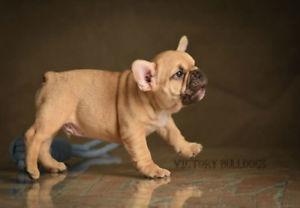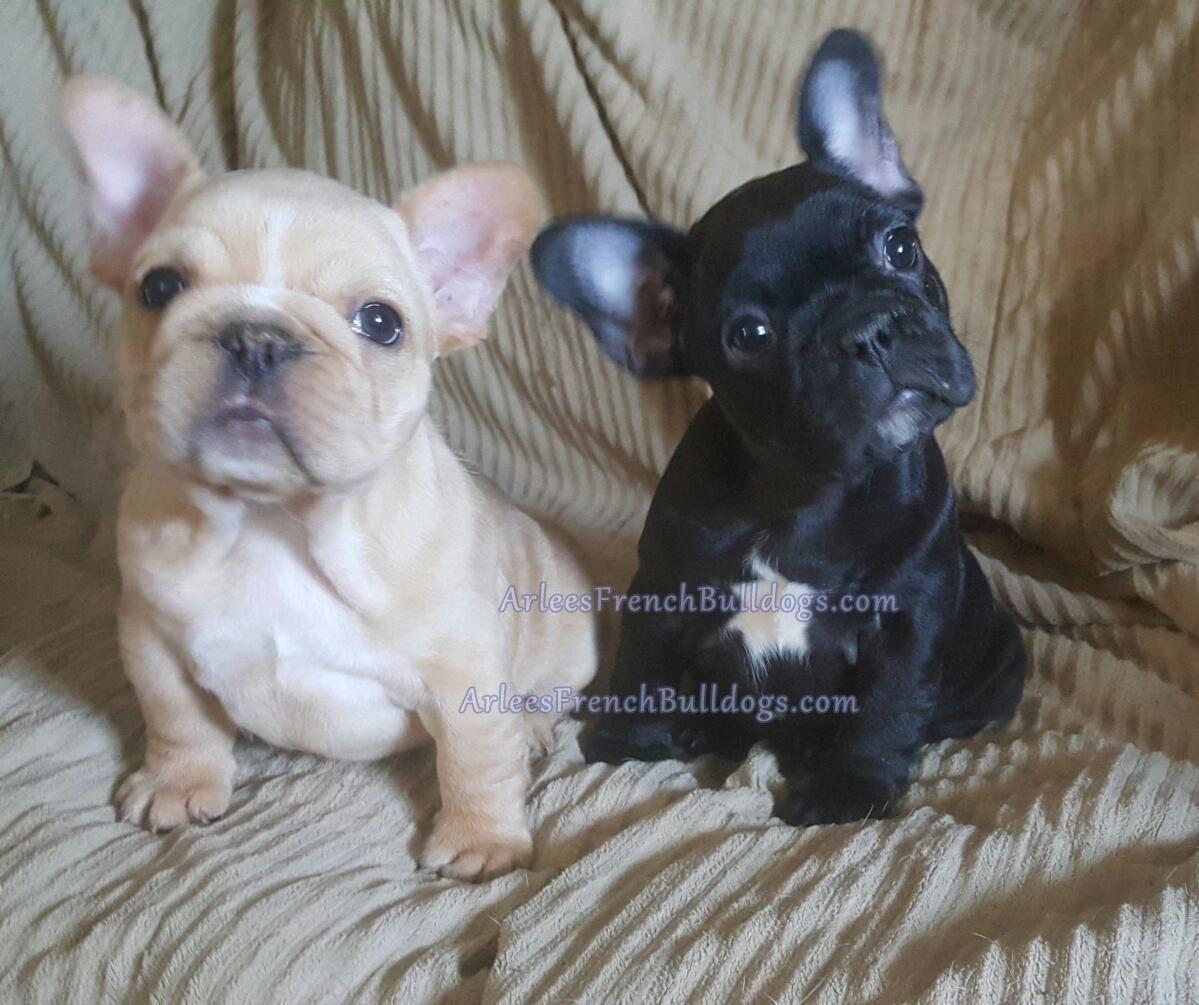The first image is the image on the left, the second image is the image on the right. Examine the images to the left and right. Is the description "One image features two french bulldogs sitting upright, and the other image features a single dog." accurate? Answer yes or no. Yes. The first image is the image on the left, the second image is the image on the right. Assess this claim about the two images: "One of the images features a dog that is wearing a collar.". Correct or not? Answer yes or no. No. 